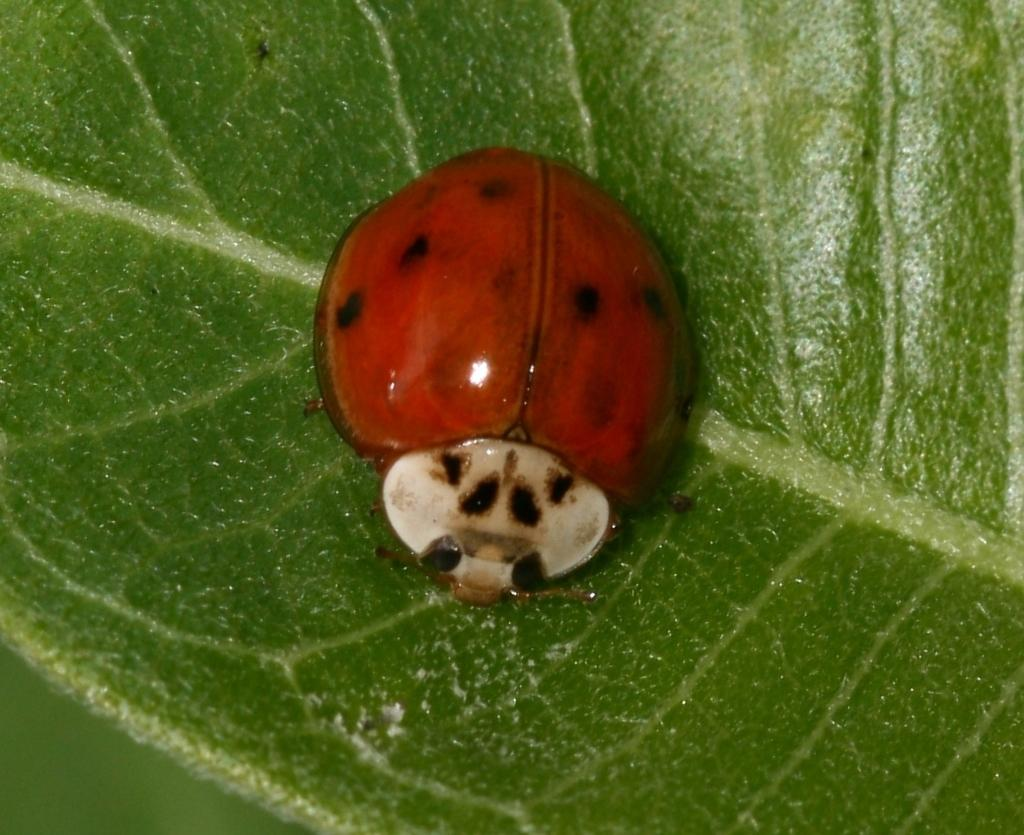What type of creature is present in the image? There is an insect in the image. What color is the insect? The insect is orange in color. Where is the insect located in the image? The insect is on a leaf. What type of chess piece can be seen on the playground in the image? There is no chess piece or playground present in the image; it features an orange insect on a leaf. What type of furniture is visible in the image? There is no furniture present in the image; it features an orange insect on a leaf. 